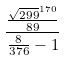Convert formula to latex. <formula><loc_0><loc_0><loc_500><loc_500>\frac { \frac { \sqrt { 2 9 9 } ^ { 1 7 0 } } { 8 9 } } { \frac { 8 } { 3 7 6 } - 1 }</formula> 